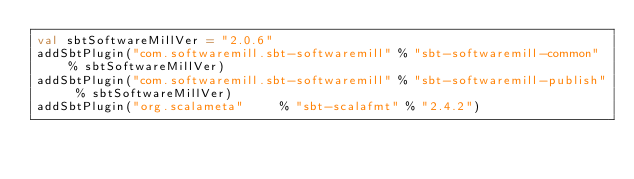Convert code to text. <code><loc_0><loc_0><loc_500><loc_500><_Scala_>val sbtSoftwareMillVer = "2.0.6"
addSbtPlugin("com.softwaremill.sbt-softwaremill" % "sbt-softwaremill-common" % sbtSoftwareMillVer)
addSbtPlugin("com.softwaremill.sbt-softwaremill" % "sbt-softwaremill-publish" % sbtSoftwareMillVer)
addSbtPlugin("org.scalameta"     % "sbt-scalafmt" % "2.4.2")
</code> 